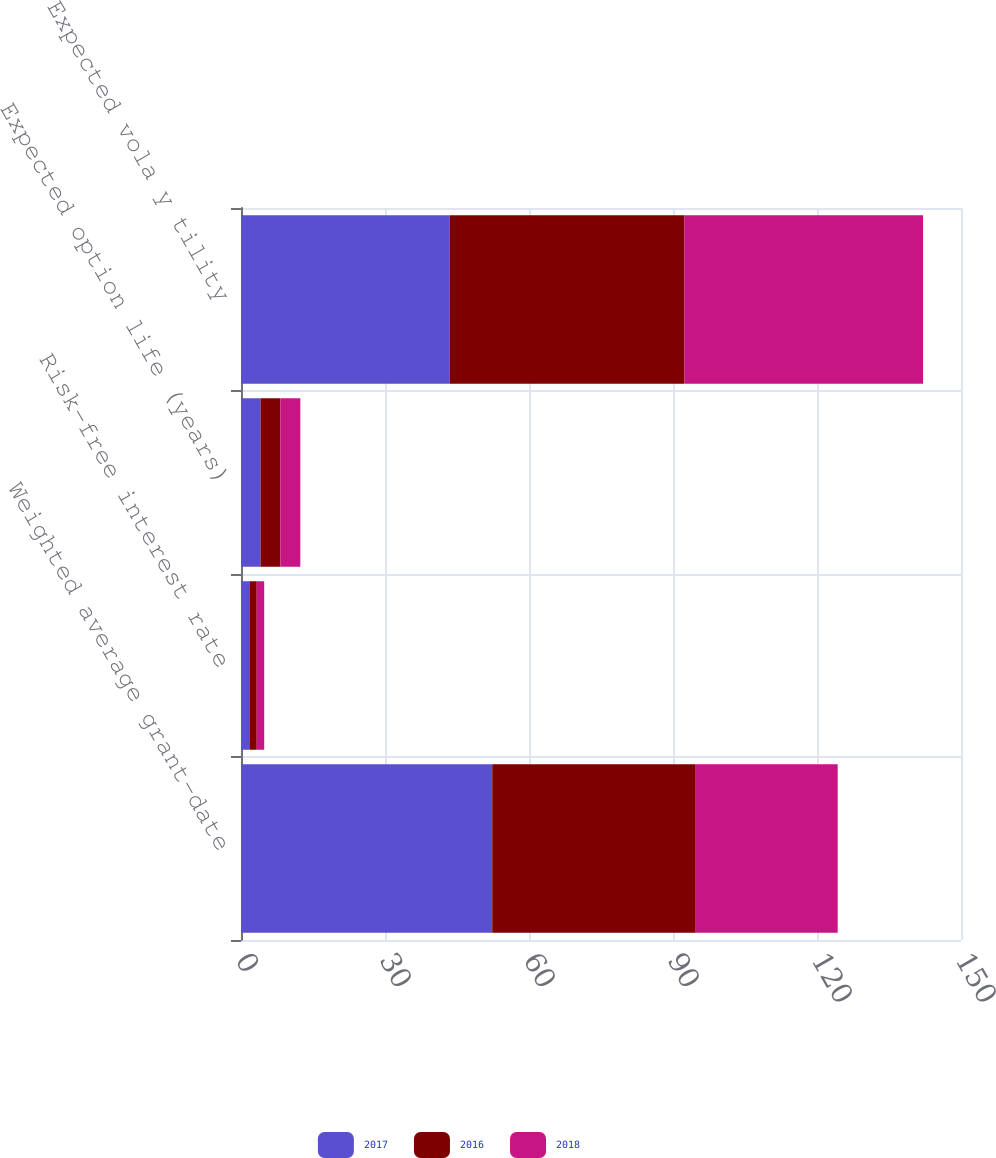Convert chart to OTSL. <chart><loc_0><loc_0><loc_500><loc_500><stacked_bar_chart><ecel><fcel>Weighted average grant-date<fcel>Risk-free interest rate<fcel>Expected option life (years)<fcel>Expected vola y tility<nl><fcel>2017<fcel>52.34<fcel>1.87<fcel>4.07<fcel>43.5<nl><fcel>2016<fcel>42.4<fcel>1.41<fcel>4.14<fcel>48.9<nl><fcel>2018<fcel>29.57<fcel>1.55<fcel>4.15<fcel>49.7<nl></chart> 